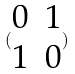Convert formula to latex. <formula><loc_0><loc_0><loc_500><loc_500>( \begin{matrix} 0 & 1 \\ 1 & 0 \end{matrix} )</formula> 